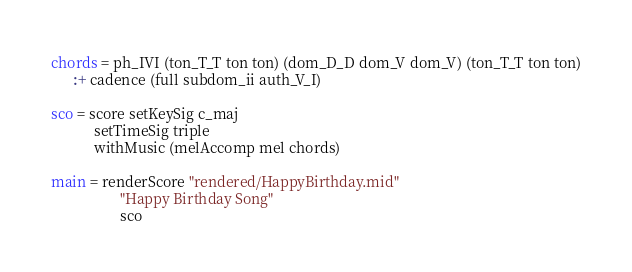<code> <loc_0><loc_0><loc_500><loc_500><_Haskell_>chords = ph_IVI (ton_T_T ton ton) (dom_D_D dom_V dom_V) (ton_T_T ton ton)
      :+ cadence (full subdom_ii auth_V_I)

sco = score setKeySig c_maj
            setTimeSig triple
            withMusic (melAccomp mel chords)

main = renderScore "rendered/HappyBirthday.mid"
                   "Happy Birthday Song"
                   sco
</code> 